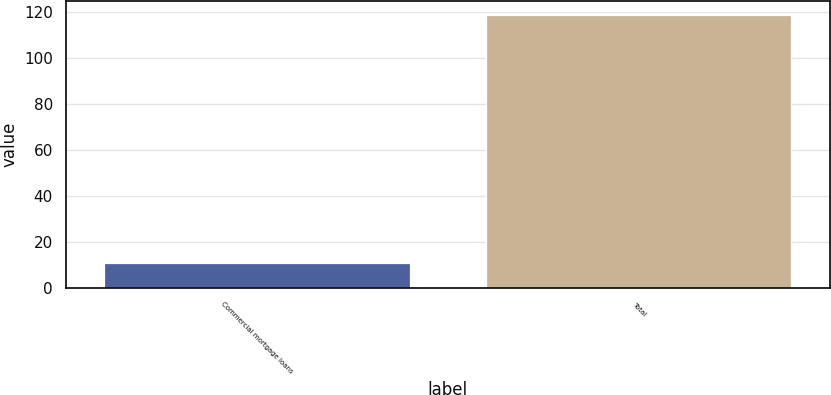<chart> <loc_0><loc_0><loc_500><loc_500><bar_chart><fcel>Commercial mortgage loans<fcel>Total<nl><fcel>11<fcel>119<nl></chart> 